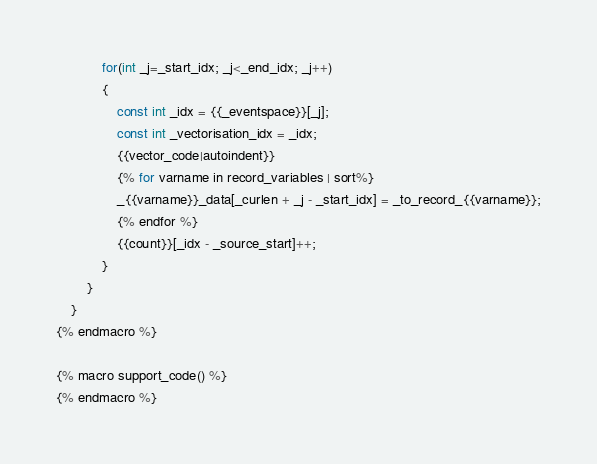<code> <loc_0><loc_0><loc_500><loc_500><_C++_>            for(int _j=_start_idx; _j<_end_idx; _j++)
            {
                const int _idx = {{_eventspace}}[_j];
                const int _vectorisation_idx = _idx;
                {{vector_code|autoindent}}
                {% for varname in record_variables | sort%}
                _{{varname}}_data[_curlen + _j - _start_idx] = _to_record_{{varname}};
                {% endfor %}
                {{count}}[_idx - _source_start]++;
            }
        }
    }
{% endmacro %}

{% macro support_code() %}
{% endmacro %}
</code> 